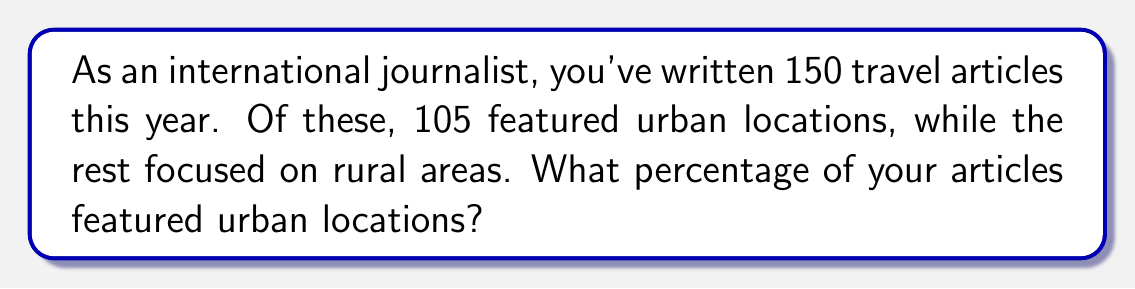Teach me how to tackle this problem. To solve this problem, we need to follow these steps:

1. Identify the total number of articles: 150
2. Identify the number of articles featuring urban locations: 105
3. Calculate the percentage using the formula:

   $$ \text{Percentage} = \frac{\text{Number of urban articles}}{\text{Total number of articles}} \times 100\% $$

Let's plug in the numbers:

$$ \text{Percentage of urban articles} = \frac{105}{150} \times 100\% $$

To simplify this fraction, we can divide both the numerator and denominator by their greatest common divisor (GCD). The GCD of 105 and 150 is 15.

$$ \frac{105}{150} = \frac{105 \div 15}{150 \div 15} = \frac{7}{10} $$

Now we can calculate:

$$ \frac{7}{10} \times 100\% = 70\% $$

Therefore, 70% of the articles featured urban locations.
Answer: 70% 